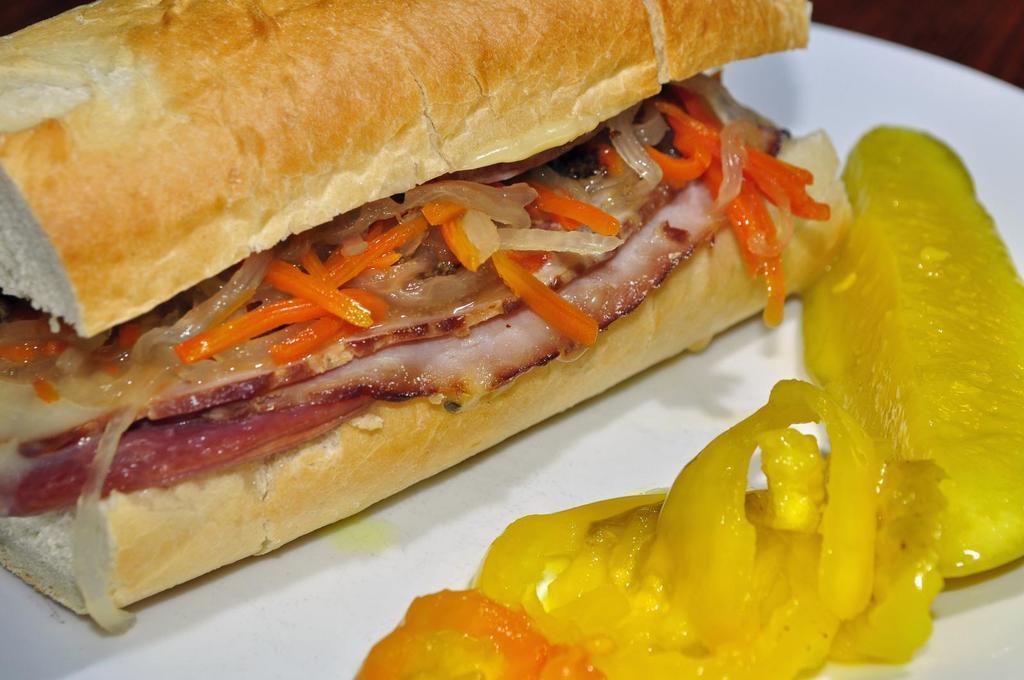Describe this image in one or two sentences. In this picture I can see the white plate in front, on which I can see food which is of brown, yellow, cream, red and orange color. 